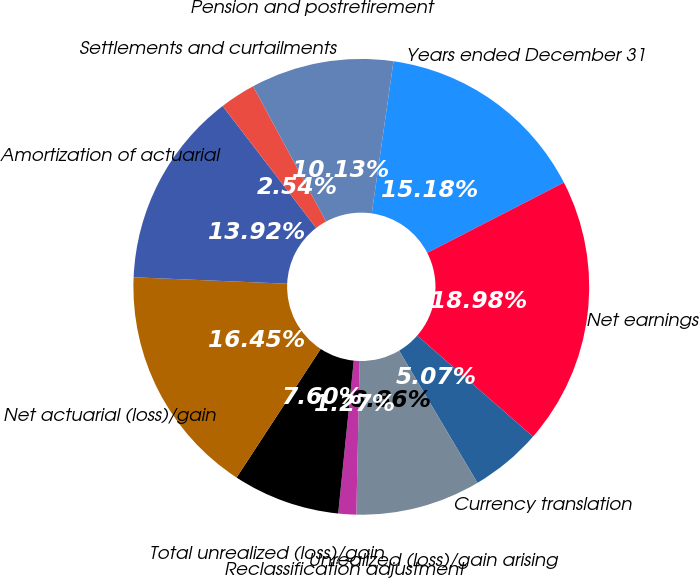<chart> <loc_0><loc_0><loc_500><loc_500><pie_chart><fcel>Years ended December 31<fcel>Net earnings<fcel>Currency translation<fcel>Unrealized (loss)/gain arising<fcel>Reclassification adjustment<fcel>Total unrealized (loss)/gain<fcel>Net actuarial (loss)/gain<fcel>Amortization of actuarial<fcel>Settlements and curtailments<fcel>Pension and postretirement<nl><fcel>15.18%<fcel>18.98%<fcel>5.07%<fcel>8.86%<fcel>1.27%<fcel>7.6%<fcel>16.45%<fcel>13.92%<fcel>2.54%<fcel>10.13%<nl></chart> 